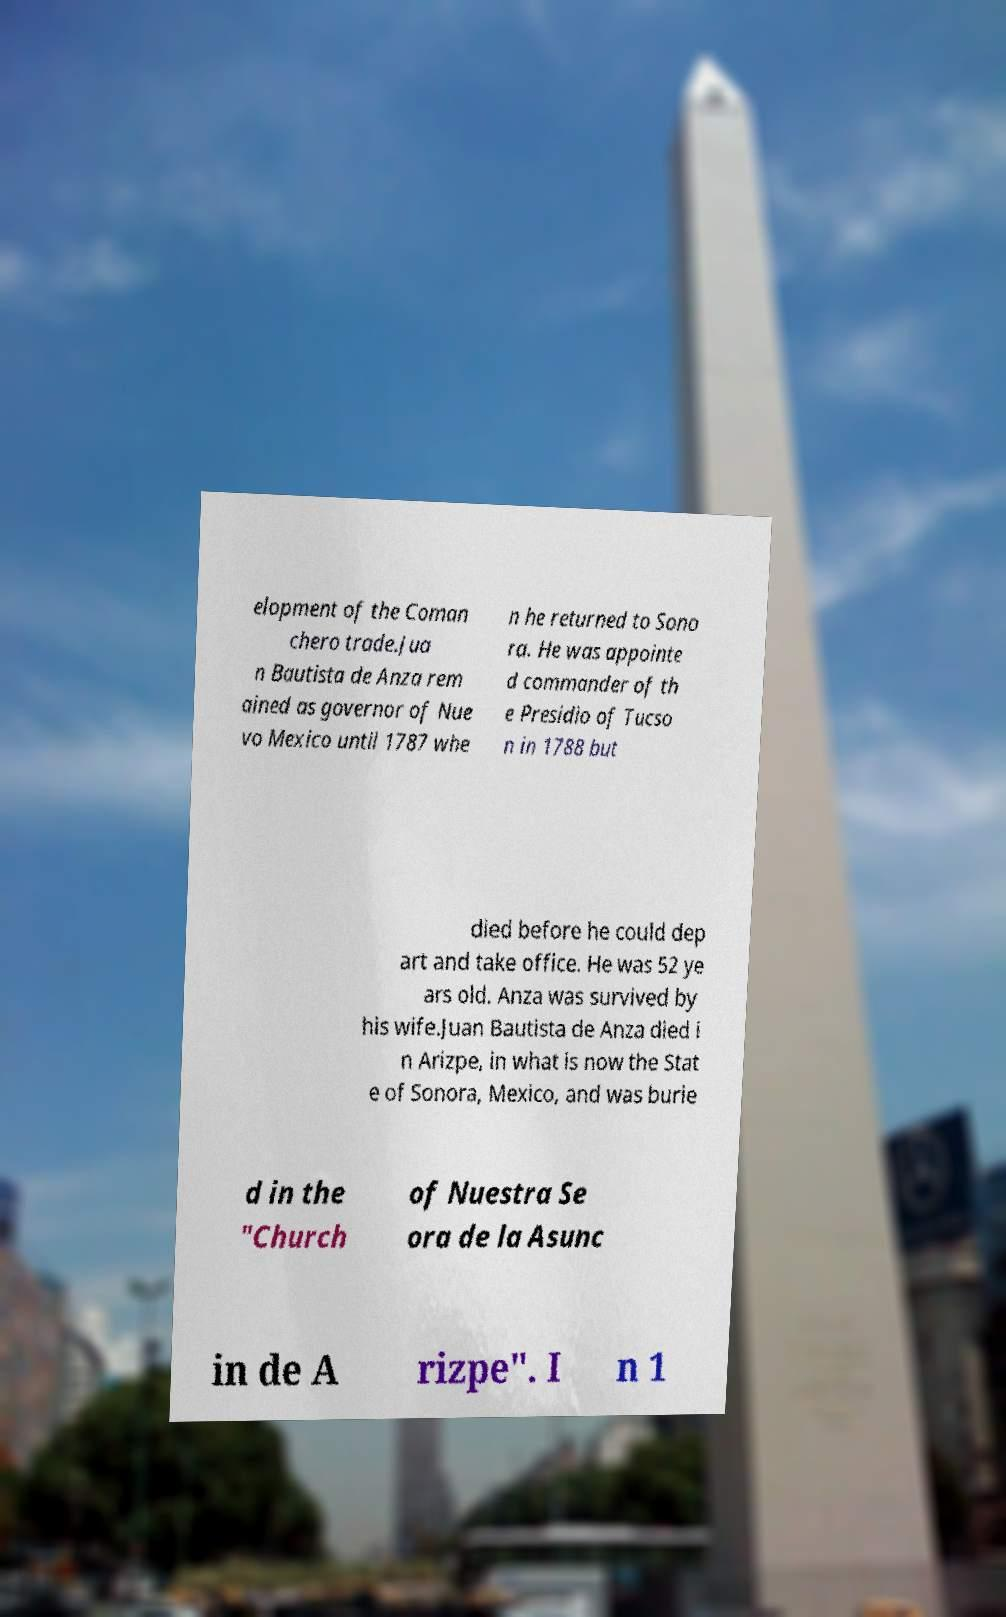What messages or text are displayed in this image? I need them in a readable, typed format. elopment of the Coman chero trade.Jua n Bautista de Anza rem ained as governor of Nue vo Mexico until 1787 whe n he returned to Sono ra. He was appointe d commander of th e Presidio of Tucso n in 1788 but died before he could dep art and take office. He was 52 ye ars old. Anza was survived by his wife.Juan Bautista de Anza died i n Arizpe, in what is now the Stat e of Sonora, Mexico, and was burie d in the "Church of Nuestra Se ora de la Asunc in de A rizpe". I n 1 